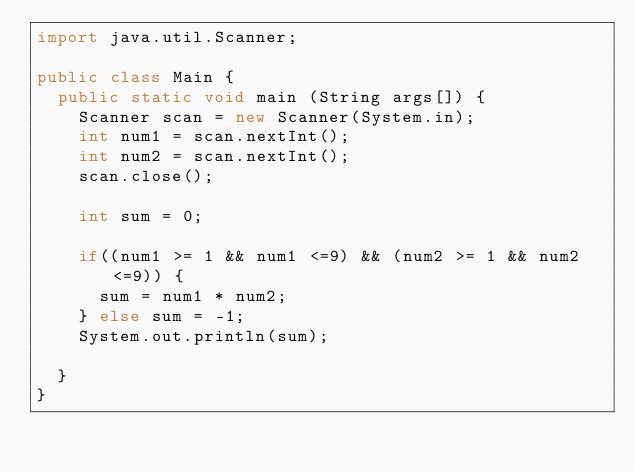Convert code to text. <code><loc_0><loc_0><loc_500><loc_500><_Java_>import java.util.Scanner;

public class Main {
	public static void main (String args[]) {
		Scanner scan = new Scanner(System.in);
		int num1 = scan.nextInt();
		int num2 = scan.nextInt();
		scan.close();
		
		int sum = 0;
		
		if((num1 >= 1 && num1 <=9) && (num2 >= 1 && num2 <=9)) {
			sum = num1 * num2;
		} else sum = -1;
		System.out.println(sum);
	
	}
}
</code> 